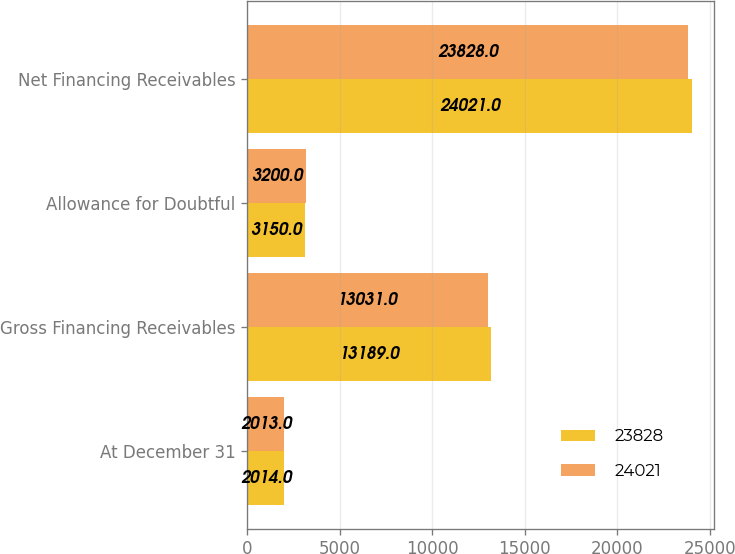<chart> <loc_0><loc_0><loc_500><loc_500><stacked_bar_chart><ecel><fcel>At December 31<fcel>Gross Financing Receivables<fcel>Allowance for Doubtful<fcel>Net Financing Receivables<nl><fcel>23828<fcel>2014<fcel>13189<fcel>3150<fcel>24021<nl><fcel>24021<fcel>2013<fcel>13031<fcel>3200<fcel>23828<nl></chart> 